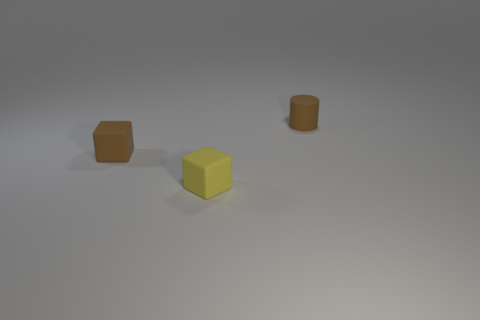Add 2 tiny red metallic cubes. How many objects exist? 5 Subtract all blocks. How many objects are left? 1 Add 2 small brown rubber cylinders. How many small brown rubber cylinders are left? 3 Add 1 big yellow things. How many big yellow things exist? 1 Subtract 0 blue cylinders. How many objects are left? 3 Subtract all yellow matte objects. Subtract all tiny yellow cubes. How many objects are left? 1 